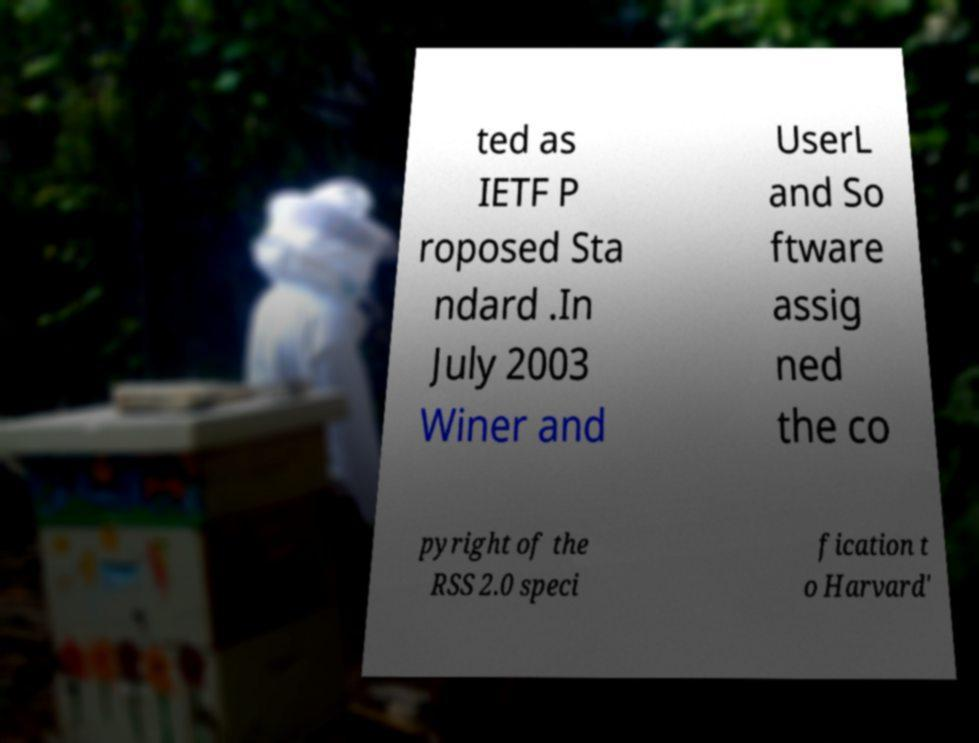Can you read and provide the text displayed in the image?This photo seems to have some interesting text. Can you extract and type it out for me? ted as IETF P roposed Sta ndard .In July 2003 Winer and UserL and So ftware assig ned the co pyright of the RSS 2.0 speci fication t o Harvard' 